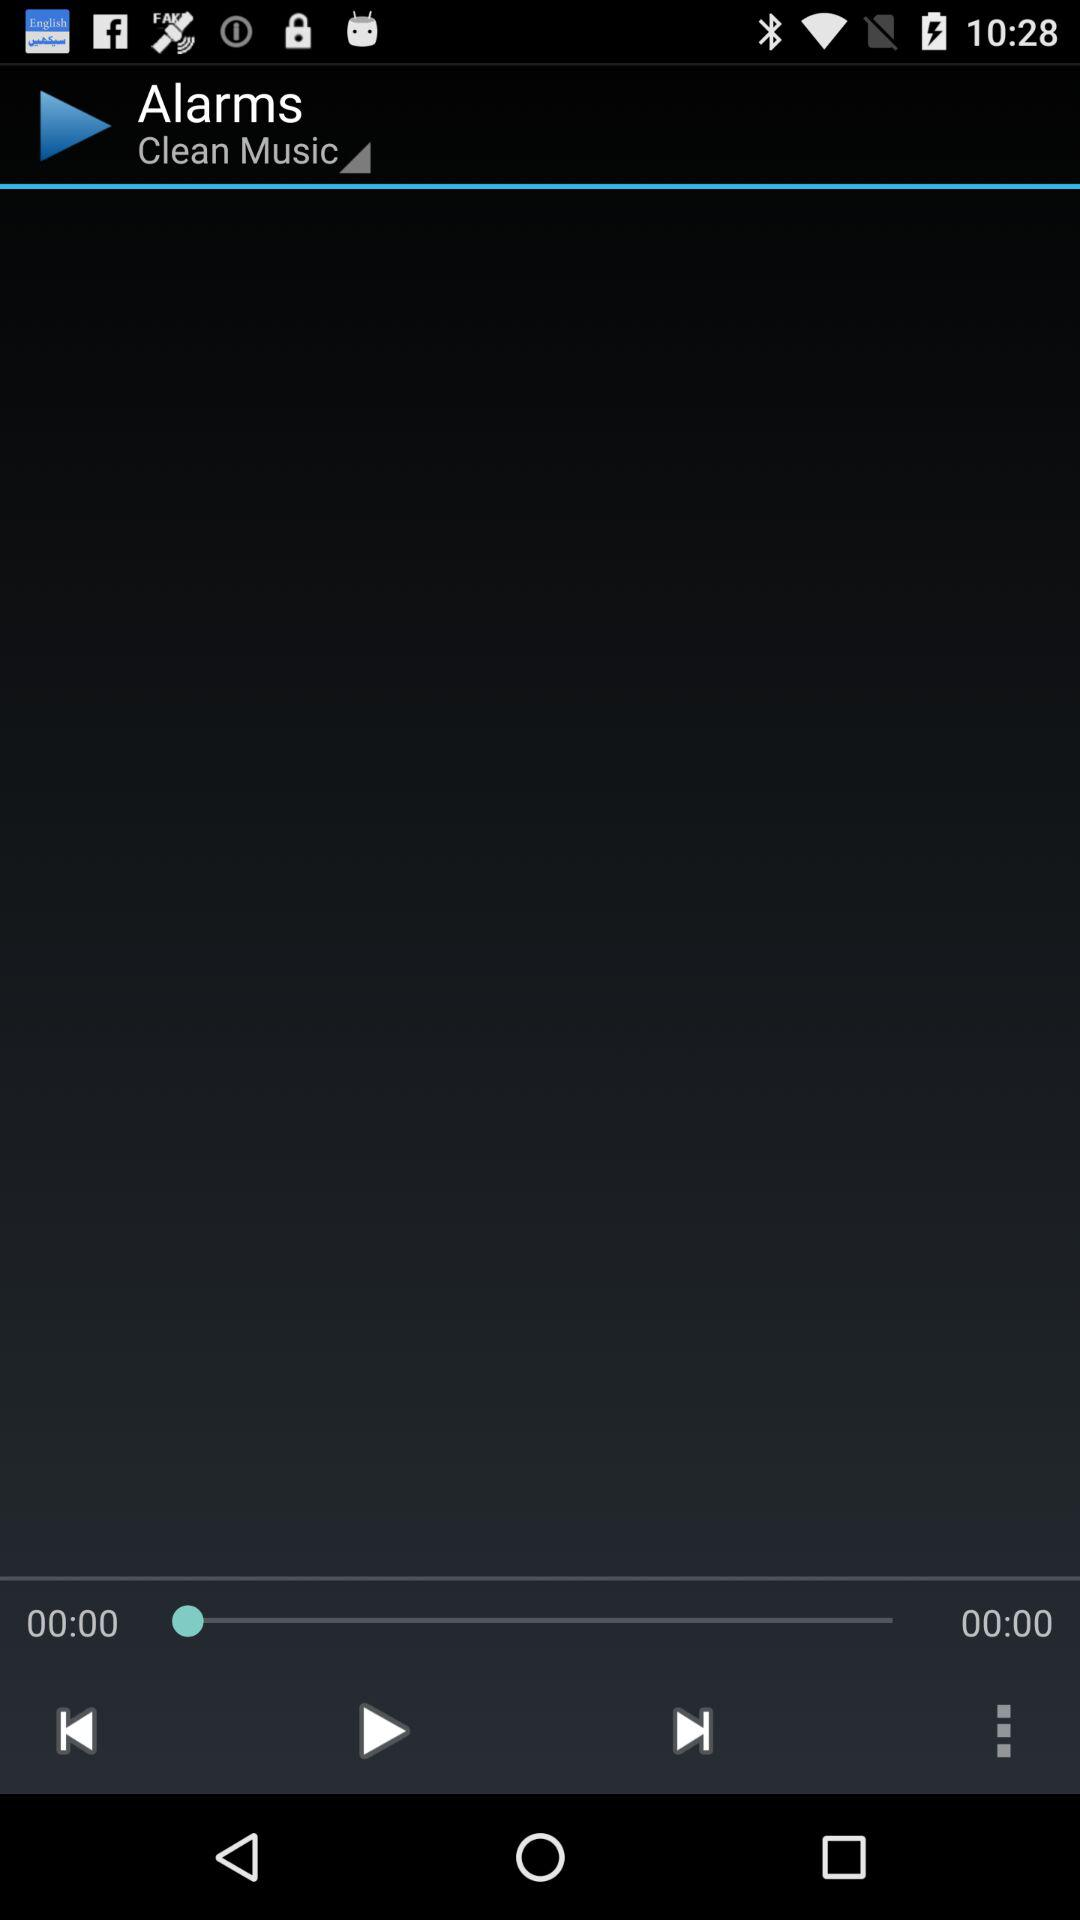What's the duration of the track? The duration of the track is 0 seconds. 